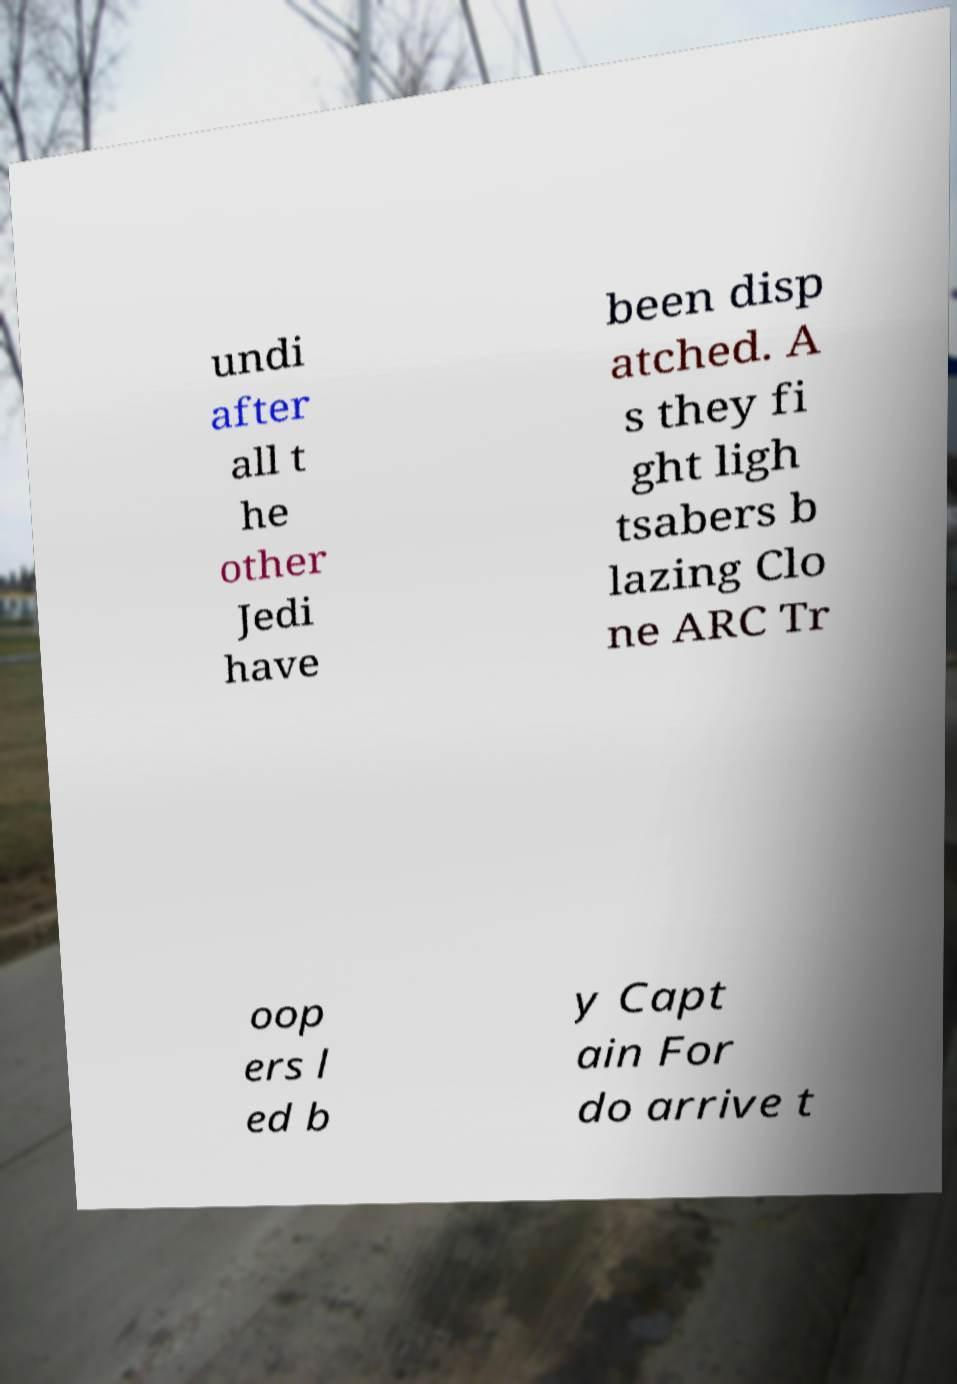What messages or text are displayed in this image? I need them in a readable, typed format. undi after all t he other Jedi have been disp atched. A s they fi ght ligh tsabers b lazing Clo ne ARC Tr oop ers l ed b y Capt ain For do arrive t 